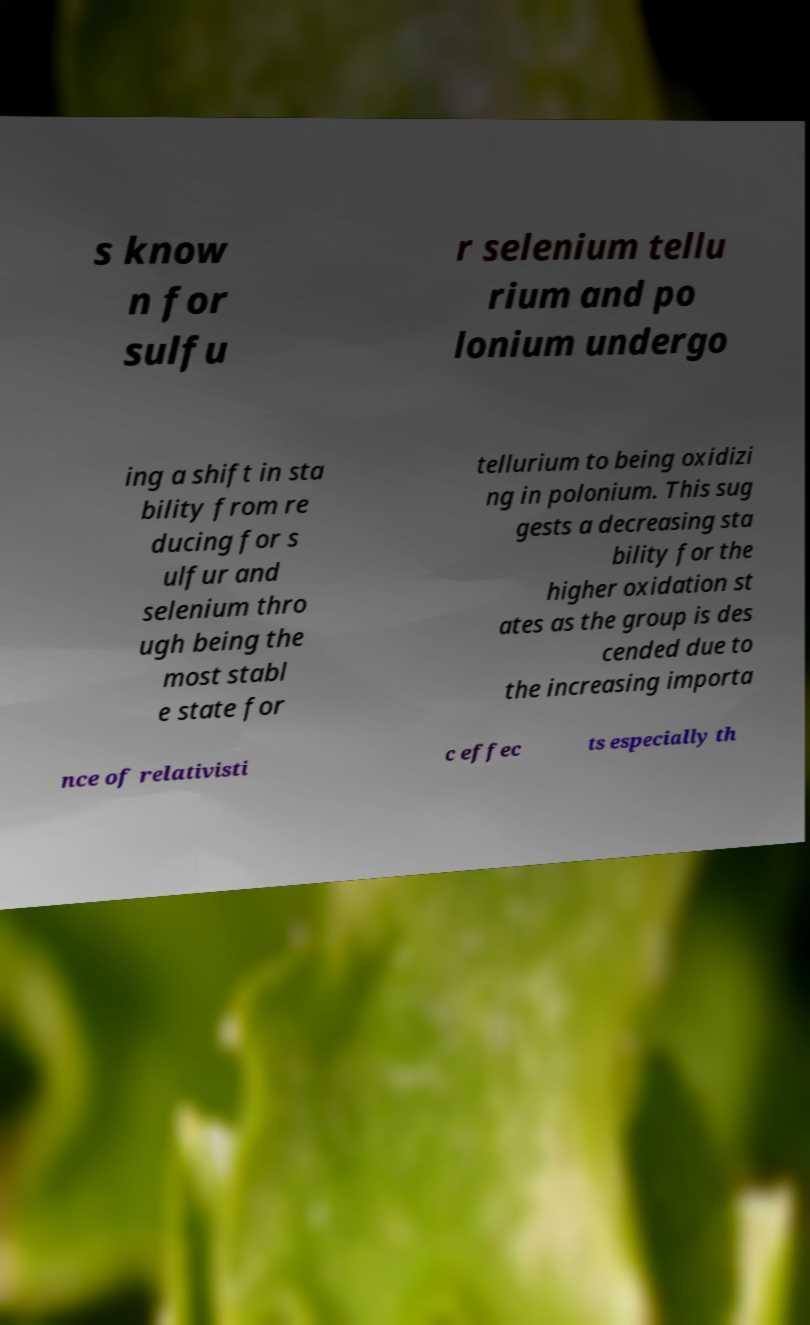Could you extract and type out the text from this image? s know n for sulfu r selenium tellu rium and po lonium undergo ing a shift in sta bility from re ducing for s ulfur and selenium thro ugh being the most stabl e state for tellurium to being oxidizi ng in polonium. This sug gests a decreasing sta bility for the higher oxidation st ates as the group is des cended due to the increasing importa nce of relativisti c effec ts especially th 